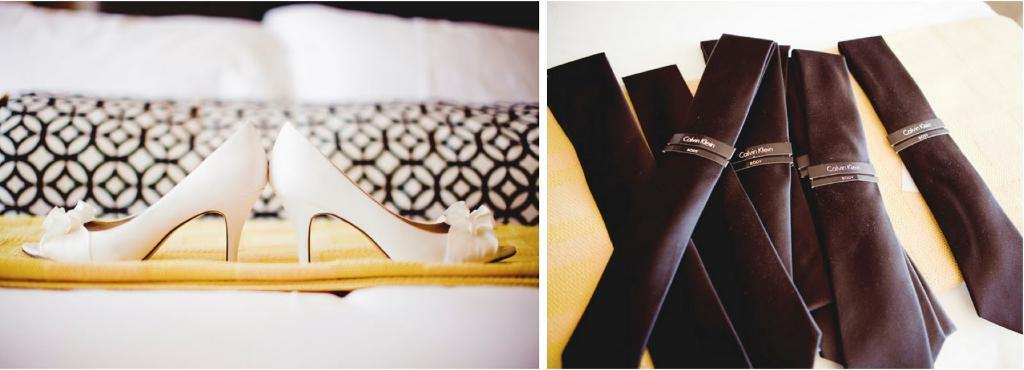What type of artwork is the image? The image is a collage. What items can be seen on the right side of the image? There are ties on a table on the right side of the image. What items can be seen on the left side of the image? There are heels and cushions on a sofa on the left side of the image. What type of food is being served on the shelf in the image? There is no shelf or food present in the image. What story is being told through the collage in the image? The collage does not tell a story; it is a collection of images and items. 